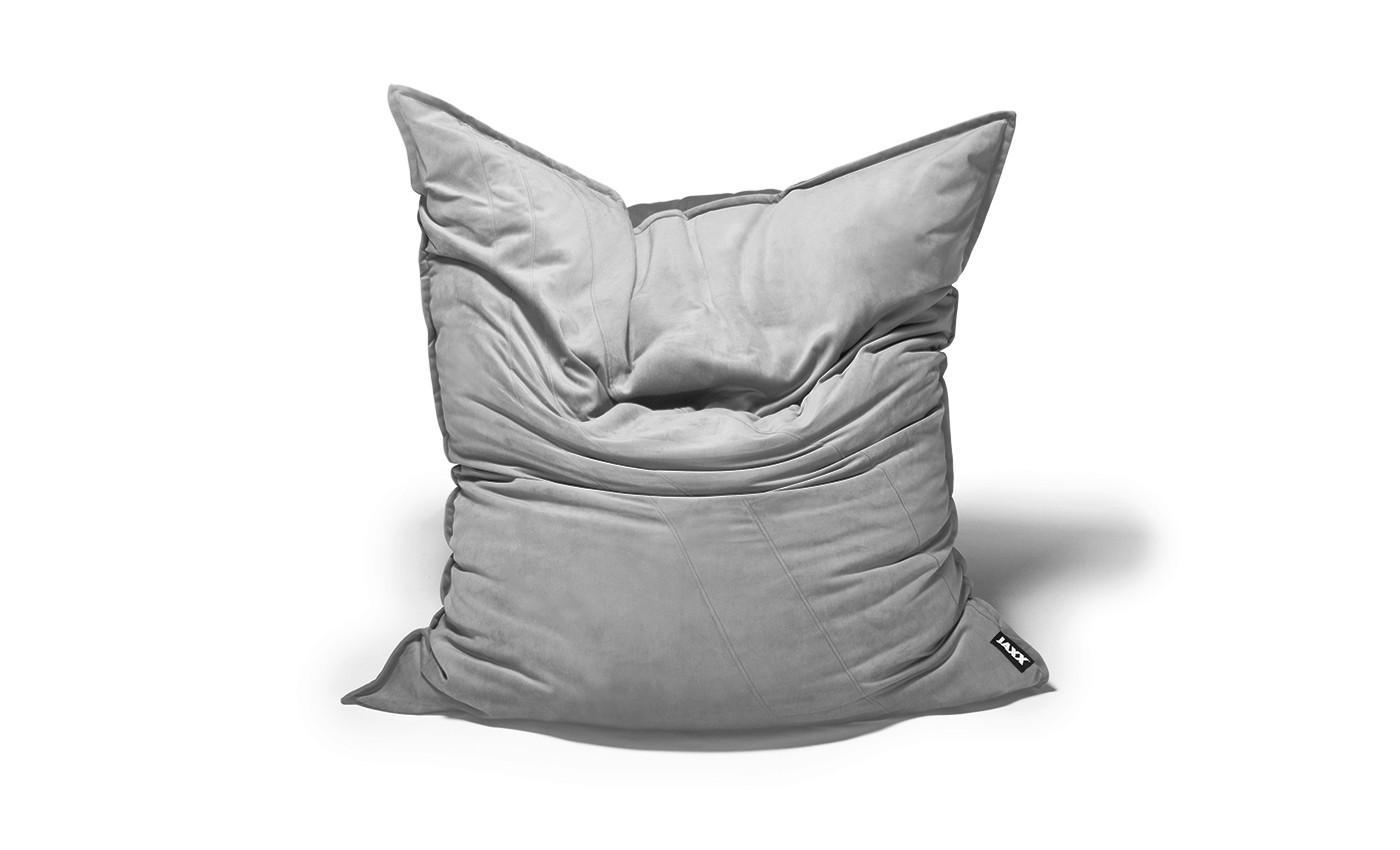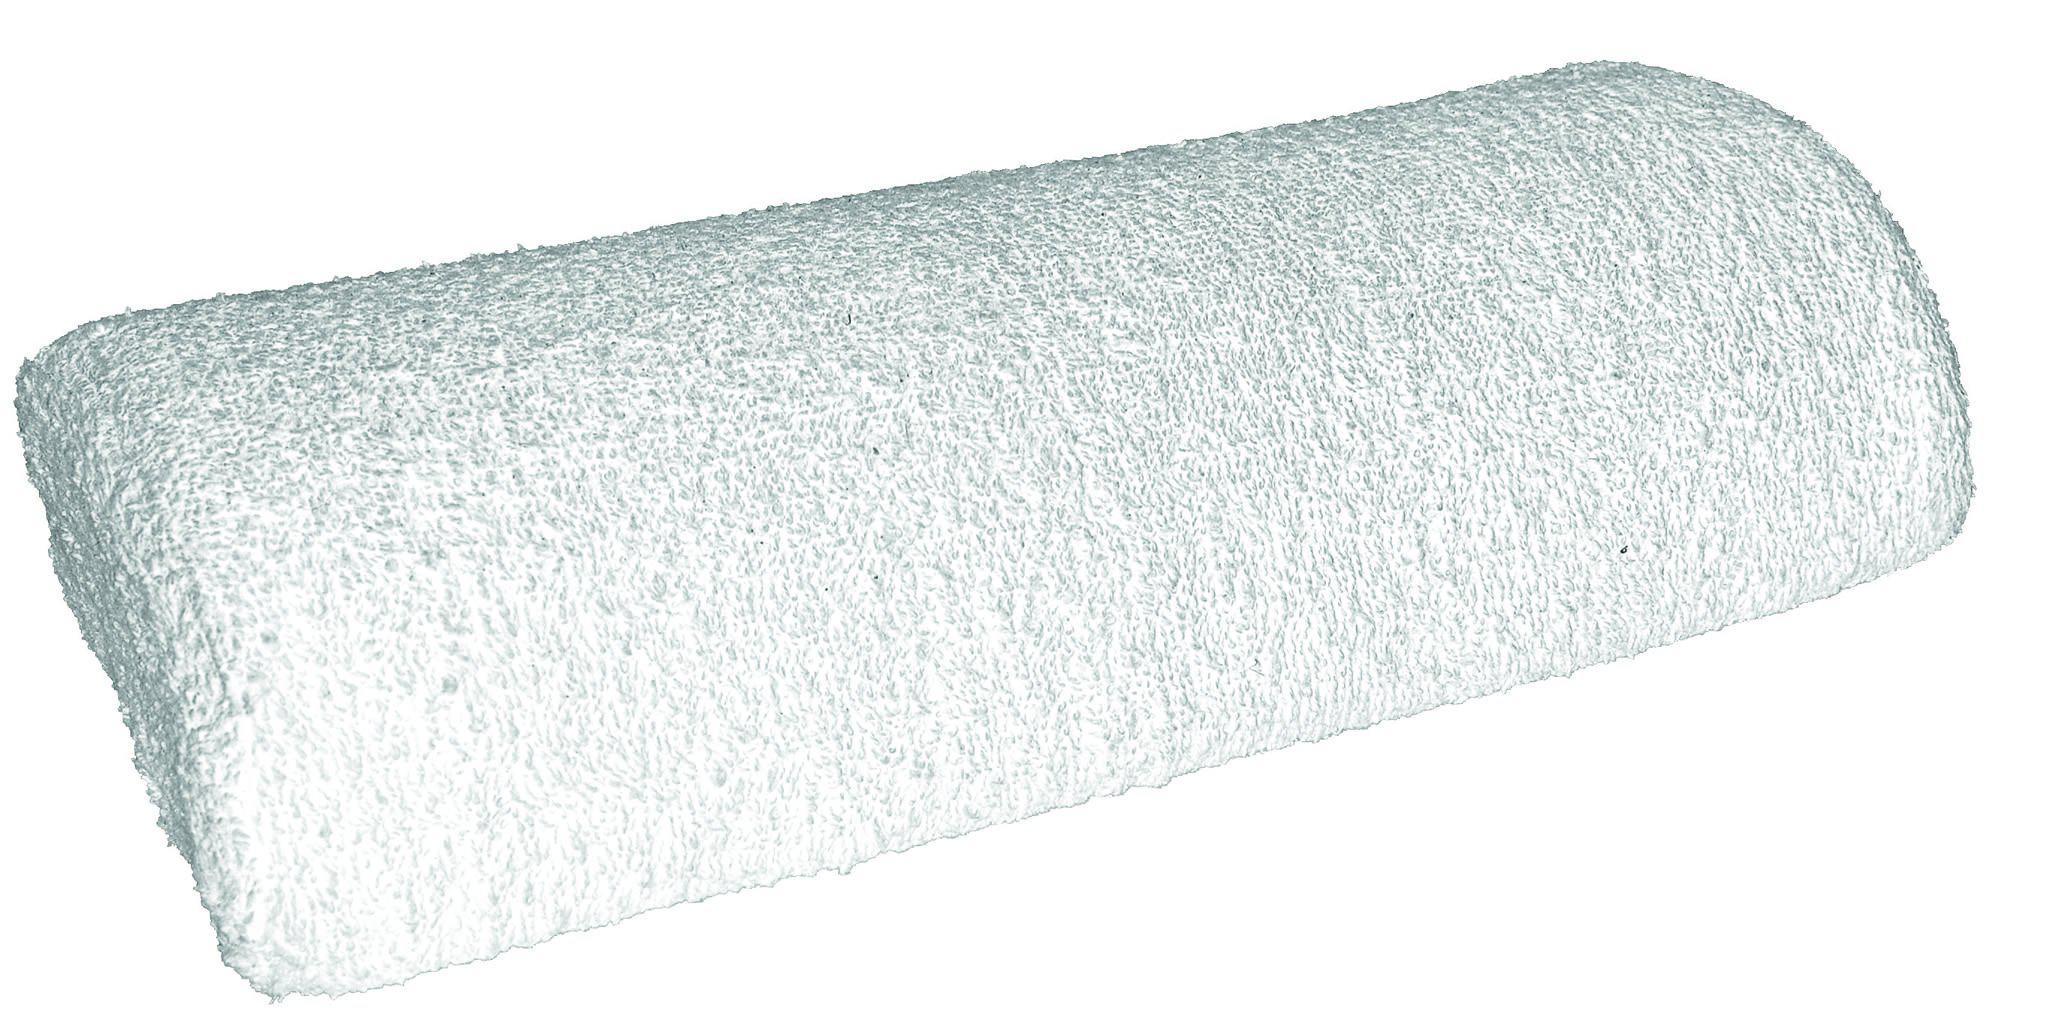The first image is the image on the left, the second image is the image on the right. Given the left and right images, does the statement "At least one of the cushions is knitted." hold true? Answer yes or no. No. The first image is the image on the left, the second image is the image on the right. Considering the images on both sides, is "The pillow is in front of a bench" valid? Answer yes or no. No. 